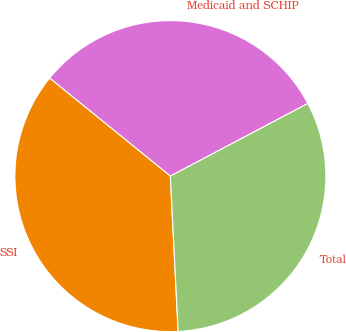Convert chart to OTSL. <chart><loc_0><loc_0><loc_500><loc_500><pie_chart><fcel>Medicaid and SCHIP<fcel>SSI<fcel>Total<nl><fcel>31.41%<fcel>36.65%<fcel>31.94%<nl></chart> 